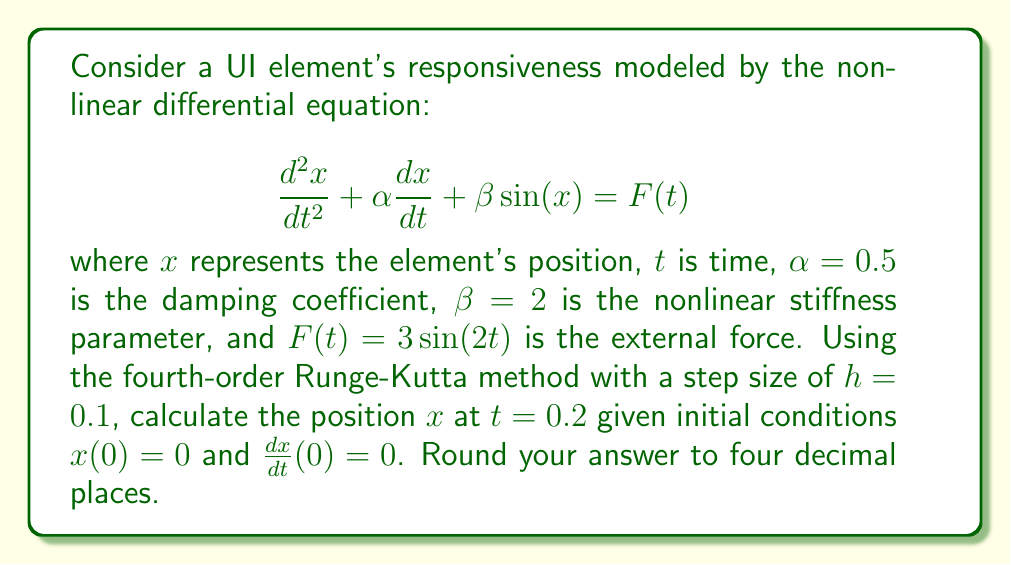Give your solution to this math problem. To solve this problem, we need to apply the fourth-order Runge-Kutta method to a system of two first-order differential equations. Let's break it down step by step:

1) First, we rewrite the second-order ODE as a system of two first-order ODEs:
   Let $y = \frac{dx}{dt}$, then:
   $$\frac{dx}{dt} = y$$
   $$\frac{dy}{dt} = -\alpha y - \beta \sin(x) + F(t) = -0.5y - 2\sin(x) + 3\sin(2t)$$

2) The fourth-order Runge-Kutta method for a system of two equations is:

   $$x_{n+1} = x_n + \frac{1}{6}(k_{1x} + 2k_{2x} + 2k_{3x} + k_{4x})$$
   $$y_{n+1} = y_n + \frac{1}{6}(k_{1y} + 2k_{2y} + 2k_{3y} + k_{4y})$$

   where:
   $$k_{1x} = hf(t_n, x_n, y_n)$$
   $$k_{1y} = hg(t_n, x_n, y_n)$$
   $$k_{2x} = hf(t_n + \frac{h}{2}, x_n + \frac{k_{1x}}{2}, y_n + \frac{k_{1y}}{2})$$
   $$k_{2y} = hg(t_n + \frac{h}{2}, x_n + \frac{k_{1x}}{2}, y_n + \frac{k_{1y}}{2})$$
   $$k_{3x} = hf(t_n + \frac{h}{2}, x_n + \frac{k_{2x}}{2}, y_n + \frac{k_{2y}}{2})$$
   $$k_{3y} = hg(t_n + \frac{h}{2}, x_n + \frac{k_{2x}}{2}, y_n + \frac{k_{2y}}{2})$$
   $$k_{4x} = hf(t_n + h, x_n + k_{3x}, y_n + k_{3y})$$
   $$k_{4y} = hg(t_n + h, x_n + k_{3x}, y_n + k_{3y})$$

3) In our case:
   $f(t, x, y) = y$
   $g(t, x, y) = -0.5y - 2\sin(x) + 3\sin(2t)$

4) We need to perform two steps to reach $t = 0.2$. Let's calculate for the first step ($n = 0$):

   $t_0 = 0$, $x_0 = 0$, $y_0 = 0$, $h = 0.1$

   $k_{1x} = 0.1 \cdot 0 = 0$
   $k_{1y} = 0.1 \cdot (0 - 0 + 0) = 0$

   $k_{2x} = 0.1 \cdot 0 = 0$
   $k_{2y} = 0.1 \cdot (-0.5 \cdot 0 - 2\sin(0) + 3\sin(0.1)) = 0.0299$

   $k_{3x} = 0.1 \cdot 0.001495 = 0.0001495$
   $k_{3y} = 0.1 \cdot (-0.5 \cdot 0.001495 - 2\sin(0.00007475) + 3\sin(0.1)) = 0.0299$

   $k_{4x} = 0.1 \cdot 0.002985 = 0.0002985$
   $k_{4y} = 0.1 \cdot (-0.5 \cdot 0.002985 - 2\sin(0.0001495) + 3\sin(0.2)) = 0.0596$

   $x_1 = 0 + \frac{1}{6}(0 + 2 \cdot 0 + 2 \cdot 0.0001495 + 0.0002985) = 0.0000995$
   $y_1 = 0 + \frac{1}{6}(0 + 2 \cdot 0.0299 + 2 \cdot 0.0299 + 0.0596) = 0.0298$

5) Now for the second step ($n = 1$):

   $t_1 = 0.1$, $x_1 = 0.0000995$, $y_1 = 0.0298$, $h = 0.1$

   Following the same process as above, we get:

   $x_2 = 0.0029795$
   $y_2 = 0.0592$

Thus, at $t = 0.2$, $x = 0.0029795$.
Answer: $0.0030$ 